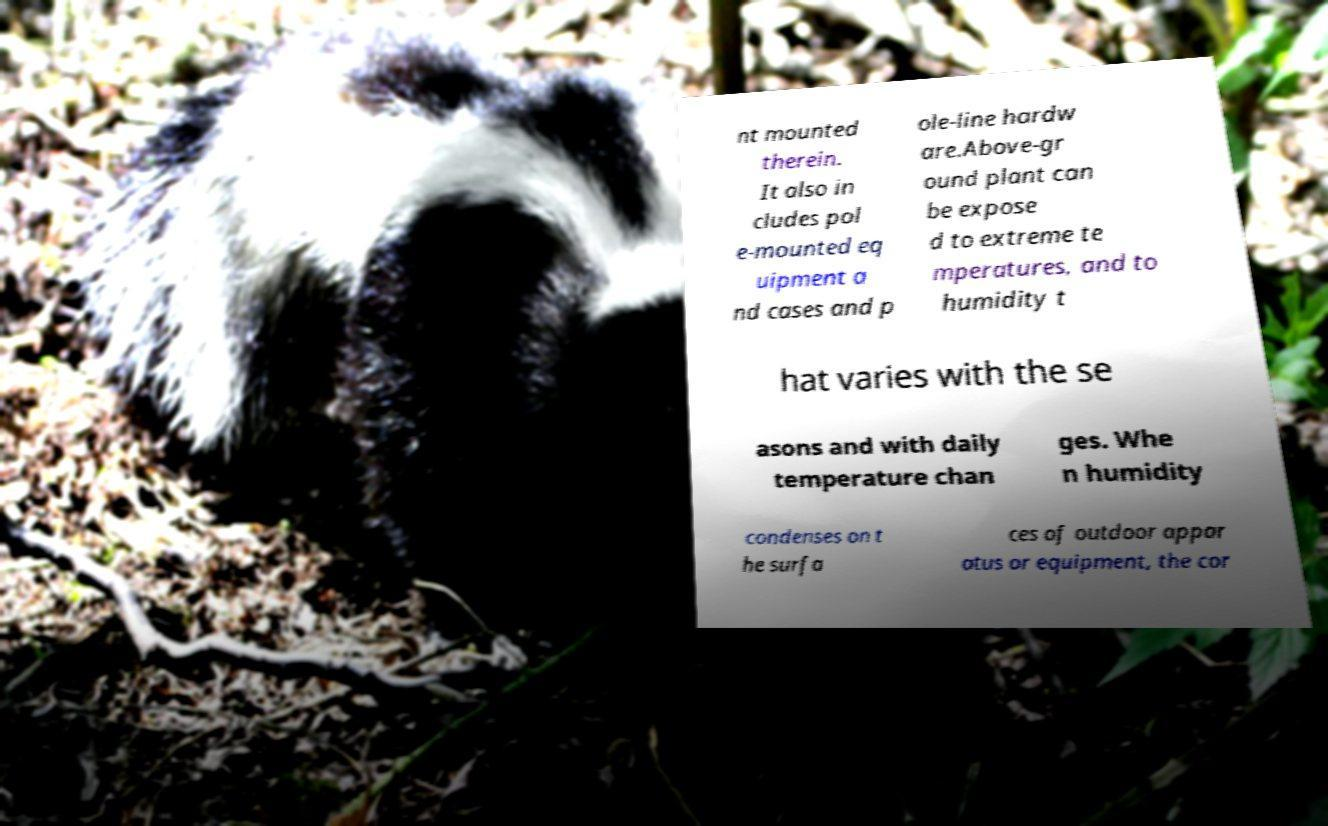Please identify and transcribe the text found in this image. nt mounted therein. It also in cludes pol e-mounted eq uipment a nd cases and p ole-line hardw are.Above-gr ound plant can be expose d to extreme te mperatures, and to humidity t hat varies with the se asons and with daily temperature chan ges. Whe n humidity condenses on t he surfa ces of outdoor appar atus or equipment, the cor 